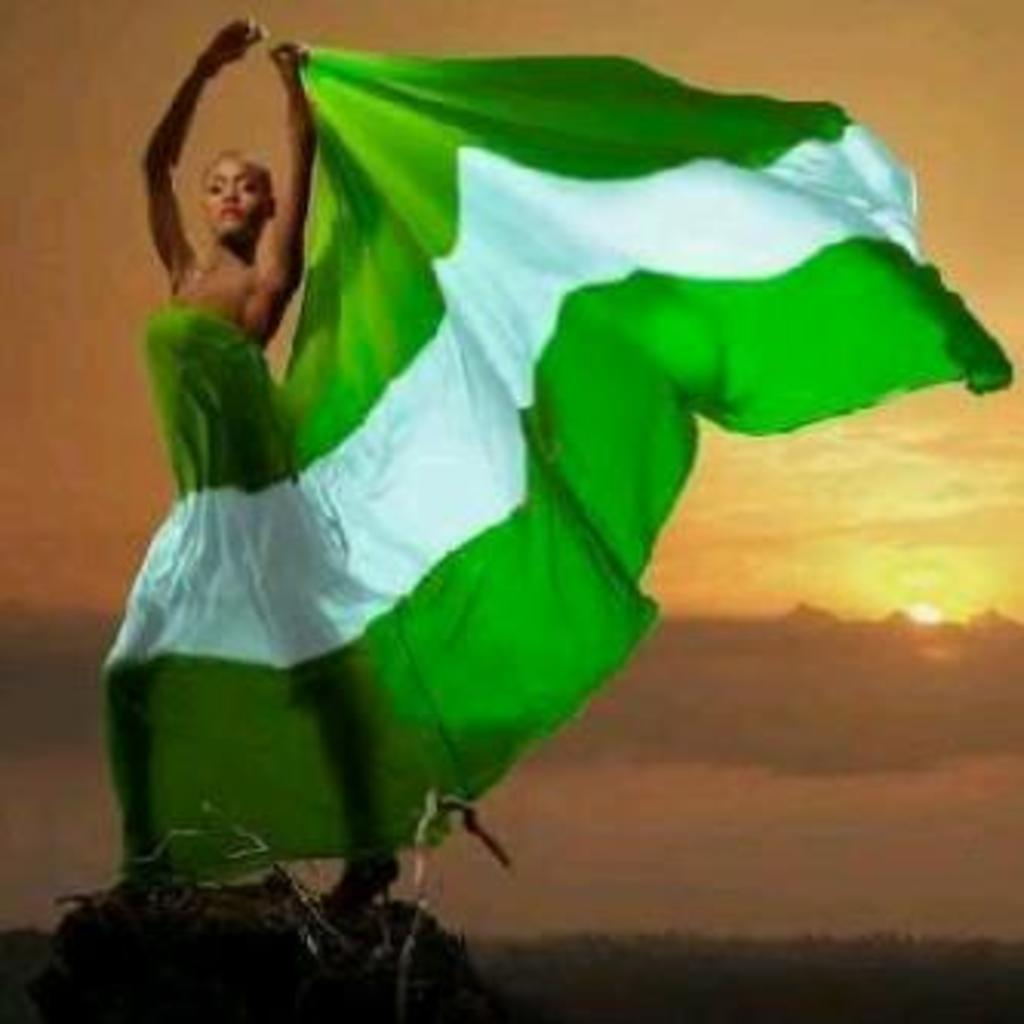What is the main subject in the image? There is a lady standing in the image. What can be seen in the background of the image? The sky is visible in the background of the image. How many bikes are being ridden by the lady in the image? There are no bikes present in the image, and the lady is not riding any bikes. What is the angle of the lady's chin in the image? There is no specific angle mentioned for the lady's chin in the image, and it cannot be determined from the provided facts. 